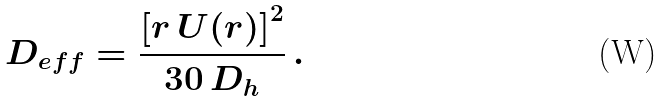Convert formula to latex. <formula><loc_0><loc_0><loc_500><loc_500>D _ { e f f } = \frac { \left [ r \, U ( r ) \right ] ^ { 2 } } { 3 0 \, D _ { h } } \, .</formula> 